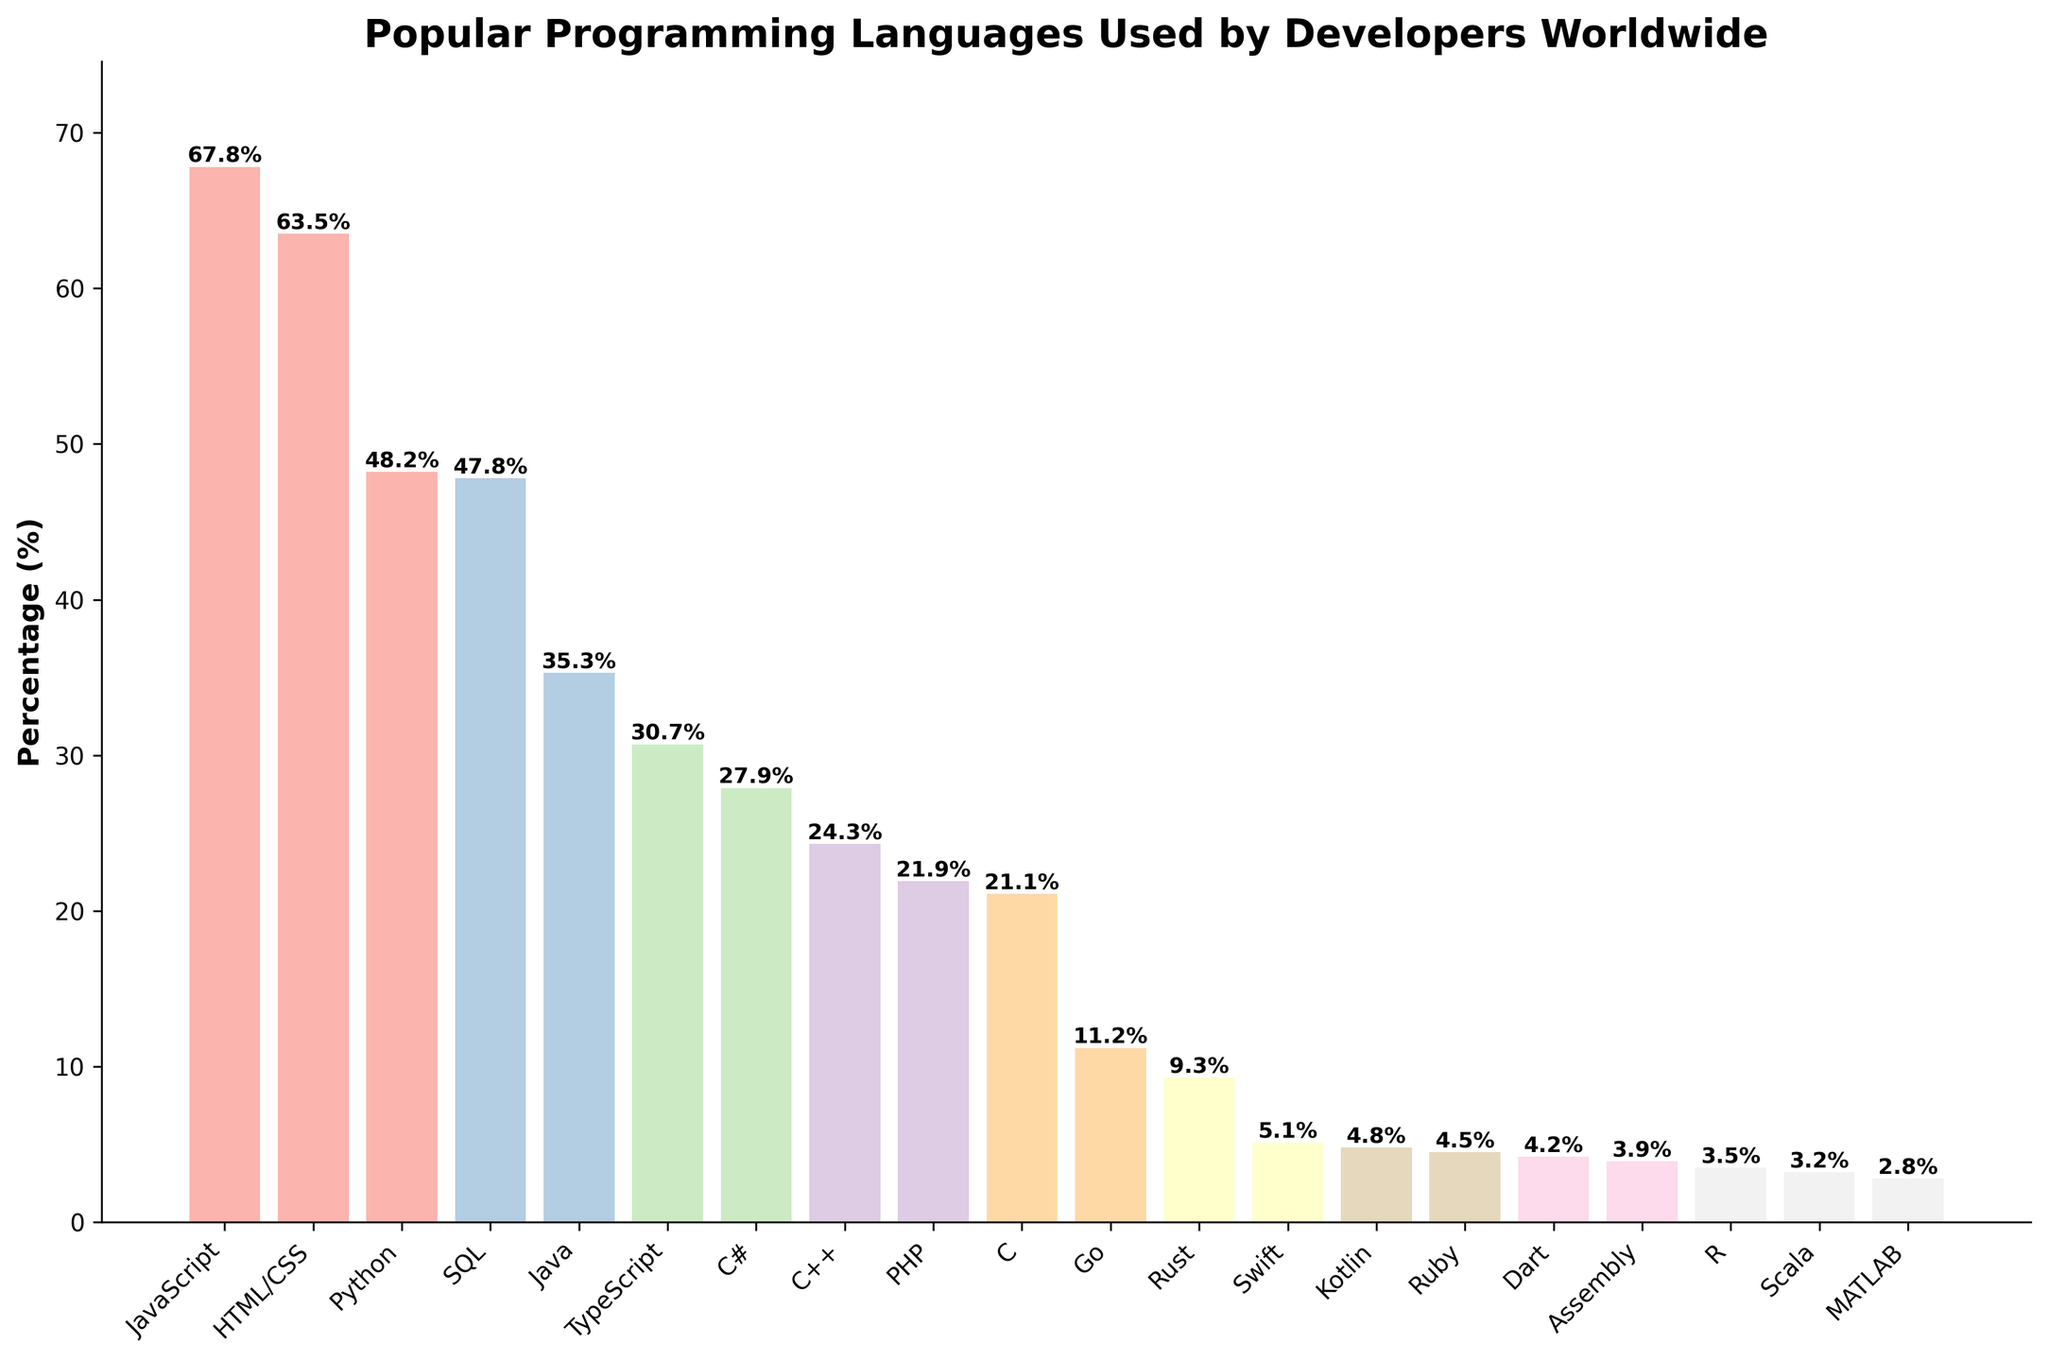what is the highest percentage of programming languages used by developers worldwide? The highest percentage bar is for JavaScript, indicated by its relative position and the label on the bar.
Answer: 67.8% Which programming language has the fourth highest percentage? By looking at the heights of the bars and their labels, the fourth highest bar, after JavaScript, HTML/CSS, and Python, is for SQL.
Answer: SQL What is the difference in percentage between Python and Java? Python has a percentage of 48.2% and Java has a percentage of 35.3%. Subtracting 35.3 from 48.2 gives the difference.
Answer: 12.9% Which two programming languages have percentages very close to each other? By reviewing the bars closely, the percentages for SQL (47.8%) and Python (48.2%) are very close.
Answer: SQL and Python What is the combined percentage of the top two programming languages? The top two programming languages are JavaScript (67.8%) and HTML/CSS (63.5%). Summing these two gives 67.8 + 63.5.
Answer: 131.3% How many programming languages have a percentage higher than 25%? By counting the bars with heights taller than the 25% mark, the programming languages are JavaScript, HTML/CSS, Python, SQL, Java, and TypeScript.
Answer: 6 Which language has a slightly higher percentage, TypeScript or C#? Comparing the heights and percentage labels on the bars, TypeScript has 30.7%, and C# has 27.9%.
Answer: TypeScript What is the percentage difference between the highest and lowest listed languages? The highest percentage is JavaScript at 67.8% and the lowest is MATLAB at 2.8%. Subtracting these gives 67.8 - 2.8.
Answer: 65.0% What is the average percentage of the three least used programming languages? The three least used languages are MATLAB (2.8%), Scala (3.2%), and R (3.5%). Summing and dividing by 3 gives (2.8 + 3.2 + 3.5) / 3.
Answer: 3.2% How does the percentage of Swift compare to Dart? Swift has a percentage of 5.1% and Dart has 4.2%. From this, Swift is higher.
Answer: Swift 